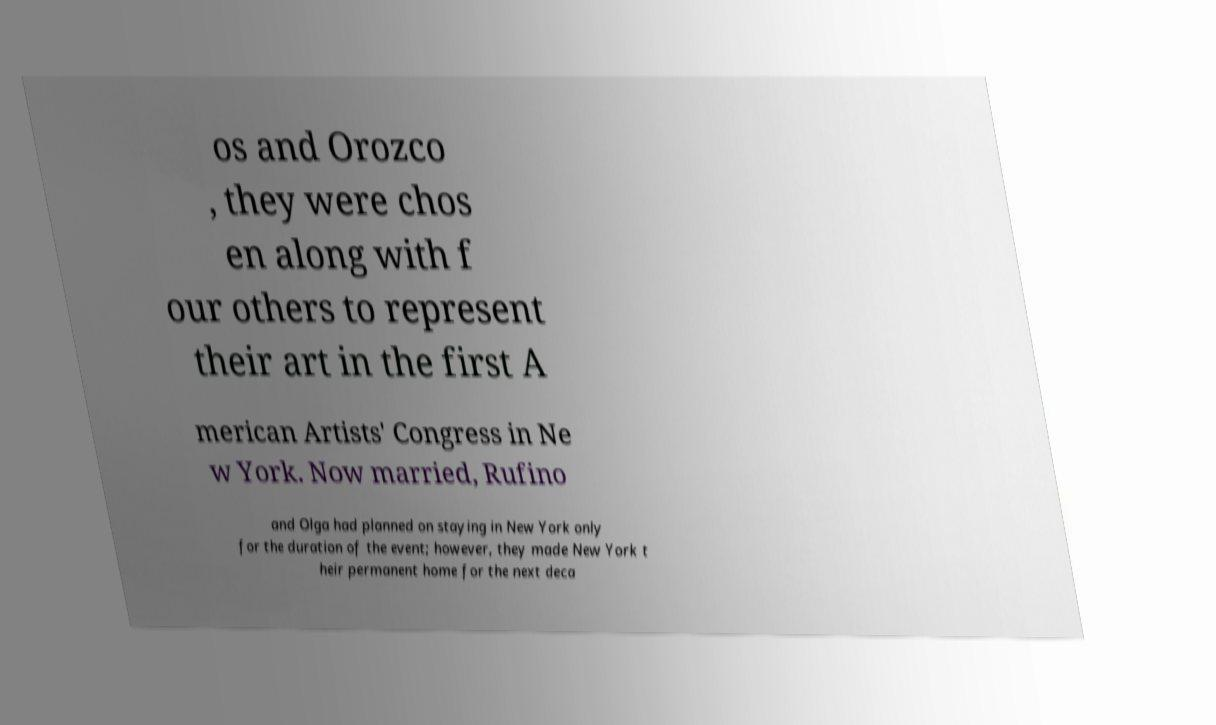Could you assist in decoding the text presented in this image and type it out clearly? os and Orozco , they were chos en along with f our others to represent their art in the first A merican Artists' Congress in Ne w York. Now married, Rufino and Olga had planned on staying in New York only for the duration of the event; however, they made New York t heir permanent home for the next deca 